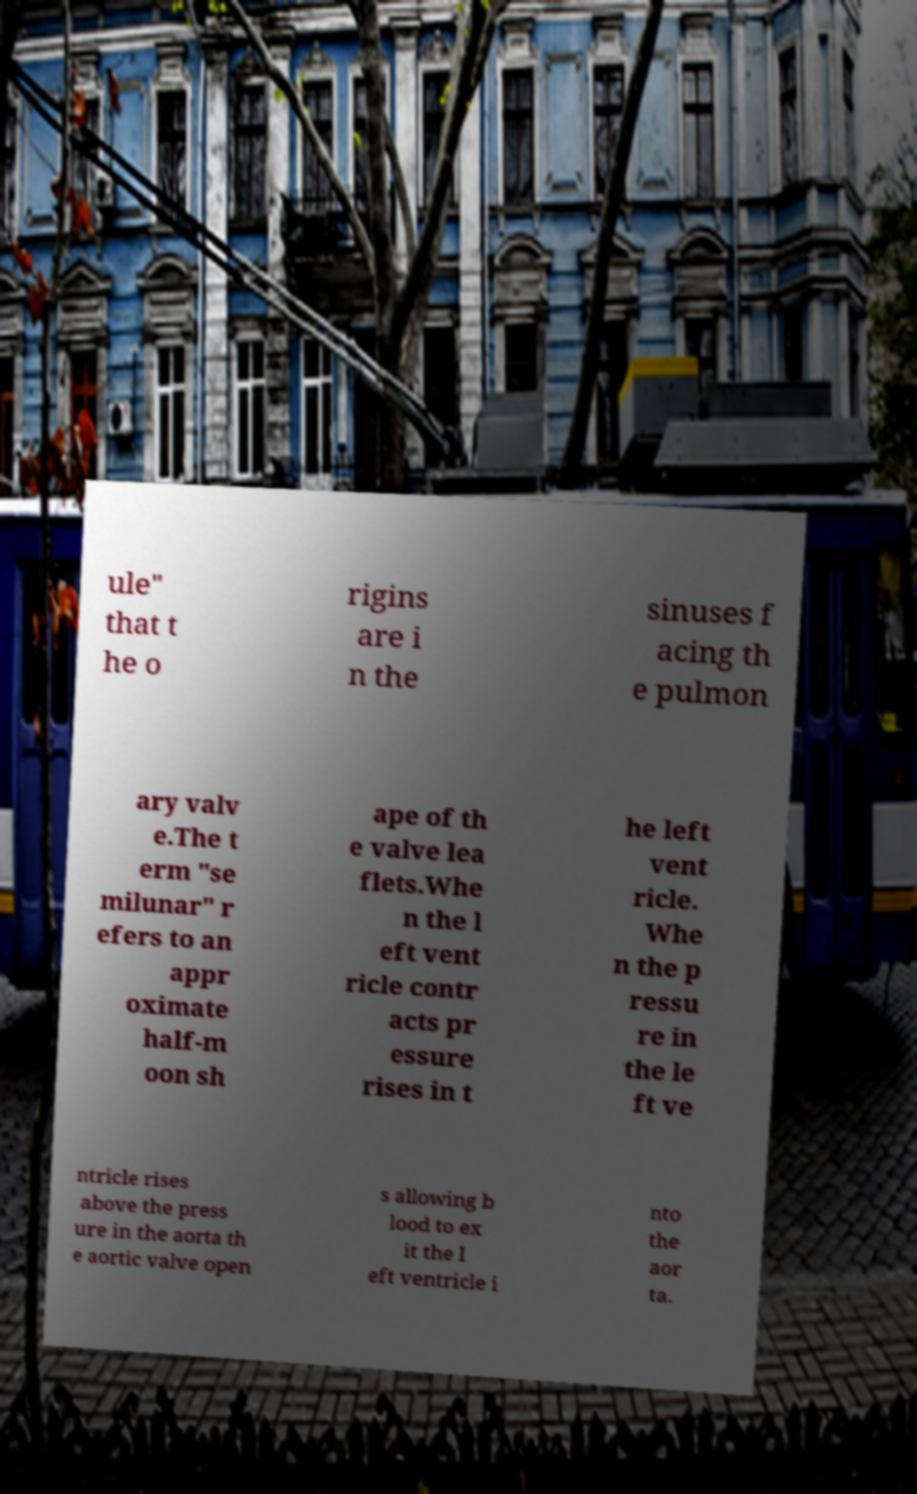Can you read and provide the text displayed in the image?This photo seems to have some interesting text. Can you extract and type it out for me? ule" that t he o rigins are i n the sinuses f acing th e pulmon ary valv e.The t erm "se milunar" r efers to an appr oximate half-m oon sh ape of th e valve lea flets.Whe n the l eft vent ricle contr acts pr essure rises in t he left vent ricle. Whe n the p ressu re in the le ft ve ntricle rises above the press ure in the aorta th e aortic valve open s allowing b lood to ex it the l eft ventricle i nto the aor ta. 